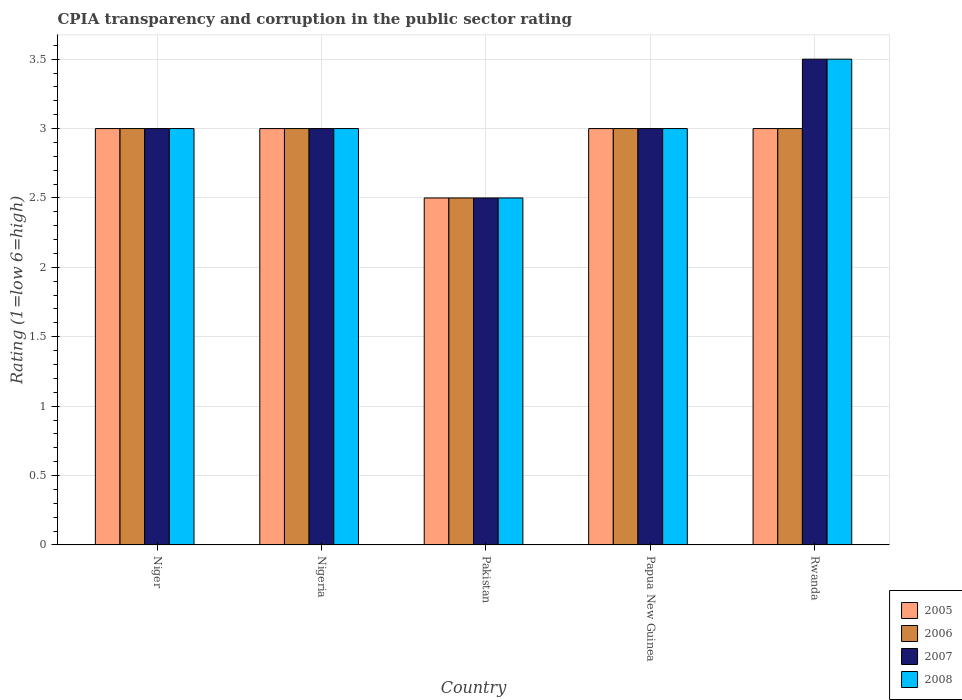Are the number of bars per tick equal to the number of legend labels?
Make the answer very short. Yes. How many bars are there on the 5th tick from the right?
Your answer should be compact. 4. What is the label of the 5th group of bars from the left?
Offer a terse response. Rwanda. In how many cases, is the number of bars for a given country not equal to the number of legend labels?
Your response must be concise. 0. What is the CPIA rating in 2007 in Niger?
Ensure brevity in your answer.  3. Across all countries, what is the maximum CPIA rating in 2008?
Give a very brief answer. 3.5. Across all countries, what is the minimum CPIA rating in 2008?
Provide a succinct answer. 2.5. In which country was the CPIA rating in 2005 maximum?
Provide a short and direct response. Niger. In which country was the CPIA rating in 2008 minimum?
Your response must be concise. Pakistan. What is the difference between the CPIA rating in 2008 in Nigeria and that in Rwanda?
Give a very brief answer. -0.5. What is the average CPIA rating in 2006 per country?
Your answer should be very brief. 2.9. What is the difference between the CPIA rating of/in 2007 and CPIA rating of/in 2006 in Rwanda?
Offer a terse response. 0.5. In how many countries, is the CPIA rating in 2008 greater than 0.30000000000000004?
Give a very brief answer. 5. What is the ratio of the CPIA rating in 2005 in Papua New Guinea to that in Rwanda?
Your response must be concise. 1. Is the CPIA rating in 2008 in Pakistan less than that in Papua New Guinea?
Offer a very short reply. Yes. Is the sum of the CPIA rating in 2006 in Pakistan and Papua New Guinea greater than the maximum CPIA rating in 2007 across all countries?
Keep it short and to the point. Yes. What does the 3rd bar from the left in Niger represents?
Provide a succinct answer. 2007. How many bars are there?
Your response must be concise. 20. Are all the bars in the graph horizontal?
Provide a succinct answer. No. How many countries are there in the graph?
Give a very brief answer. 5. Does the graph contain any zero values?
Give a very brief answer. No. Does the graph contain grids?
Make the answer very short. Yes. Where does the legend appear in the graph?
Offer a terse response. Bottom right. What is the title of the graph?
Your response must be concise. CPIA transparency and corruption in the public sector rating. What is the Rating (1=low 6=high) of 2005 in Niger?
Your answer should be very brief. 3. What is the Rating (1=low 6=high) in 2005 in Nigeria?
Offer a terse response. 3. What is the Rating (1=low 6=high) in 2008 in Pakistan?
Your answer should be very brief. 2.5. What is the Rating (1=low 6=high) of 2005 in Papua New Guinea?
Offer a very short reply. 3. What is the Rating (1=low 6=high) of 2007 in Papua New Guinea?
Provide a succinct answer. 3. What is the Rating (1=low 6=high) of 2008 in Papua New Guinea?
Your answer should be compact. 3. What is the Rating (1=low 6=high) in 2006 in Rwanda?
Offer a terse response. 3. What is the Rating (1=low 6=high) of 2007 in Rwanda?
Your answer should be compact. 3.5. Across all countries, what is the maximum Rating (1=low 6=high) in 2006?
Your response must be concise. 3. Across all countries, what is the maximum Rating (1=low 6=high) of 2008?
Keep it short and to the point. 3.5. Across all countries, what is the minimum Rating (1=low 6=high) in 2005?
Ensure brevity in your answer.  2.5. Across all countries, what is the minimum Rating (1=low 6=high) in 2006?
Make the answer very short. 2.5. Across all countries, what is the minimum Rating (1=low 6=high) of 2007?
Offer a terse response. 2.5. What is the total Rating (1=low 6=high) in 2005 in the graph?
Your response must be concise. 14.5. What is the total Rating (1=low 6=high) of 2006 in the graph?
Keep it short and to the point. 14.5. What is the total Rating (1=low 6=high) in 2008 in the graph?
Provide a succinct answer. 15. What is the difference between the Rating (1=low 6=high) of 2006 in Niger and that in Nigeria?
Provide a succinct answer. 0. What is the difference between the Rating (1=low 6=high) of 2005 in Niger and that in Pakistan?
Keep it short and to the point. 0.5. What is the difference between the Rating (1=low 6=high) of 2007 in Niger and that in Pakistan?
Your answer should be compact. 0.5. What is the difference between the Rating (1=low 6=high) of 2008 in Niger and that in Pakistan?
Your answer should be very brief. 0.5. What is the difference between the Rating (1=low 6=high) of 2005 in Niger and that in Rwanda?
Ensure brevity in your answer.  0. What is the difference between the Rating (1=low 6=high) of 2006 in Nigeria and that in Pakistan?
Offer a terse response. 0.5. What is the difference between the Rating (1=low 6=high) of 2007 in Nigeria and that in Pakistan?
Ensure brevity in your answer.  0.5. What is the difference between the Rating (1=low 6=high) of 2008 in Nigeria and that in Pakistan?
Give a very brief answer. 0.5. What is the difference between the Rating (1=low 6=high) in 2007 in Nigeria and that in Papua New Guinea?
Ensure brevity in your answer.  0. What is the difference between the Rating (1=low 6=high) of 2008 in Nigeria and that in Papua New Guinea?
Provide a short and direct response. 0. What is the difference between the Rating (1=low 6=high) of 2005 in Nigeria and that in Rwanda?
Your response must be concise. 0. What is the difference between the Rating (1=low 6=high) in 2008 in Pakistan and that in Papua New Guinea?
Your answer should be compact. -0.5. What is the difference between the Rating (1=low 6=high) in 2006 in Pakistan and that in Rwanda?
Ensure brevity in your answer.  -0.5. What is the difference between the Rating (1=low 6=high) of 2007 in Papua New Guinea and that in Rwanda?
Give a very brief answer. -0.5. What is the difference between the Rating (1=low 6=high) in 2005 in Niger and the Rating (1=low 6=high) in 2007 in Nigeria?
Ensure brevity in your answer.  0. What is the difference between the Rating (1=low 6=high) of 2006 in Niger and the Rating (1=low 6=high) of 2008 in Nigeria?
Offer a terse response. 0. What is the difference between the Rating (1=low 6=high) in 2005 in Niger and the Rating (1=low 6=high) in 2006 in Pakistan?
Offer a very short reply. 0.5. What is the difference between the Rating (1=low 6=high) of 2005 in Niger and the Rating (1=low 6=high) of 2007 in Pakistan?
Provide a short and direct response. 0.5. What is the difference between the Rating (1=low 6=high) of 2005 in Niger and the Rating (1=low 6=high) of 2008 in Pakistan?
Your answer should be compact. 0.5. What is the difference between the Rating (1=low 6=high) in 2005 in Niger and the Rating (1=low 6=high) in 2006 in Papua New Guinea?
Provide a short and direct response. 0. What is the difference between the Rating (1=low 6=high) in 2006 in Niger and the Rating (1=low 6=high) in 2008 in Papua New Guinea?
Provide a short and direct response. 0. What is the difference between the Rating (1=low 6=high) in 2007 in Niger and the Rating (1=low 6=high) in 2008 in Papua New Guinea?
Your answer should be very brief. 0. What is the difference between the Rating (1=low 6=high) of 2005 in Niger and the Rating (1=low 6=high) of 2006 in Rwanda?
Offer a very short reply. 0. What is the difference between the Rating (1=low 6=high) of 2005 in Niger and the Rating (1=low 6=high) of 2008 in Rwanda?
Offer a very short reply. -0.5. What is the difference between the Rating (1=low 6=high) in 2005 in Nigeria and the Rating (1=low 6=high) in 2008 in Pakistan?
Provide a short and direct response. 0.5. What is the difference between the Rating (1=low 6=high) of 2006 in Nigeria and the Rating (1=low 6=high) of 2008 in Pakistan?
Make the answer very short. 0.5. What is the difference between the Rating (1=low 6=high) of 2005 in Nigeria and the Rating (1=low 6=high) of 2007 in Papua New Guinea?
Keep it short and to the point. 0. What is the difference between the Rating (1=low 6=high) in 2006 in Nigeria and the Rating (1=low 6=high) in 2007 in Papua New Guinea?
Your answer should be very brief. 0. What is the difference between the Rating (1=low 6=high) in 2006 in Nigeria and the Rating (1=low 6=high) in 2008 in Papua New Guinea?
Your response must be concise. 0. What is the difference between the Rating (1=low 6=high) in 2007 in Nigeria and the Rating (1=low 6=high) in 2008 in Papua New Guinea?
Offer a very short reply. 0. What is the difference between the Rating (1=low 6=high) of 2007 in Nigeria and the Rating (1=low 6=high) of 2008 in Rwanda?
Offer a very short reply. -0.5. What is the difference between the Rating (1=low 6=high) of 2005 in Pakistan and the Rating (1=low 6=high) of 2006 in Papua New Guinea?
Ensure brevity in your answer.  -0.5. What is the difference between the Rating (1=low 6=high) of 2005 in Pakistan and the Rating (1=low 6=high) of 2008 in Papua New Guinea?
Give a very brief answer. -0.5. What is the difference between the Rating (1=low 6=high) in 2005 in Pakistan and the Rating (1=low 6=high) in 2006 in Rwanda?
Your answer should be compact. -0.5. What is the difference between the Rating (1=low 6=high) in 2005 in Pakistan and the Rating (1=low 6=high) in 2007 in Rwanda?
Offer a very short reply. -1. What is the difference between the Rating (1=low 6=high) in 2006 in Pakistan and the Rating (1=low 6=high) in 2007 in Rwanda?
Your answer should be very brief. -1. What is the difference between the Rating (1=low 6=high) of 2007 in Pakistan and the Rating (1=low 6=high) of 2008 in Rwanda?
Offer a terse response. -1. What is the difference between the Rating (1=low 6=high) in 2005 in Papua New Guinea and the Rating (1=low 6=high) in 2006 in Rwanda?
Make the answer very short. 0. What is the difference between the Rating (1=low 6=high) in 2005 in Papua New Guinea and the Rating (1=low 6=high) in 2007 in Rwanda?
Offer a very short reply. -0.5. What is the difference between the Rating (1=low 6=high) in 2005 in Papua New Guinea and the Rating (1=low 6=high) in 2008 in Rwanda?
Your answer should be very brief. -0.5. What is the average Rating (1=low 6=high) in 2006 per country?
Ensure brevity in your answer.  2.9. What is the average Rating (1=low 6=high) in 2007 per country?
Ensure brevity in your answer.  3. What is the difference between the Rating (1=low 6=high) in 2005 and Rating (1=low 6=high) in 2007 in Niger?
Offer a very short reply. 0. What is the difference between the Rating (1=low 6=high) of 2006 and Rating (1=low 6=high) of 2007 in Niger?
Ensure brevity in your answer.  0. What is the difference between the Rating (1=low 6=high) of 2006 and Rating (1=low 6=high) of 2008 in Niger?
Your answer should be very brief. 0. What is the difference between the Rating (1=low 6=high) in 2005 and Rating (1=low 6=high) in 2008 in Nigeria?
Give a very brief answer. 0. What is the difference between the Rating (1=low 6=high) in 2006 and Rating (1=low 6=high) in 2007 in Nigeria?
Your answer should be very brief. 0. What is the difference between the Rating (1=low 6=high) of 2006 and Rating (1=low 6=high) of 2008 in Nigeria?
Ensure brevity in your answer.  0. What is the difference between the Rating (1=low 6=high) of 2007 and Rating (1=low 6=high) of 2008 in Nigeria?
Offer a terse response. 0. What is the difference between the Rating (1=low 6=high) in 2005 and Rating (1=low 6=high) in 2007 in Pakistan?
Your answer should be compact. 0. What is the difference between the Rating (1=low 6=high) of 2005 and Rating (1=low 6=high) of 2008 in Pakistan?
Make the answer very short. 0. What is the difference between the Rating (1=low 6=high) of 2006 and Rating (1=low 6=high) of 2007 in Pakistan?
Your response must be concise. 0. What is the difference between the Rating (1=low 6=high) in 2005 and Rating (1=low 6=high) in 2006 in Papua New Guinea?
Your answer should be compact. 0. What is the difference between the Rating (1=low 6=high) of 2005 and Rating (1=low 6=high) of 2007 in Papua New Guinea?
Ensure brevity in your answer.  0. What is the difference between the Rating (1=low 6=high) in 2005 and Rating (1=low 6=high) in 2008 in Papua New Guinea?
Your answer should be compact. 0. What is the difference between the Rating (1=low 6=high) of 2006 and Rating (1=low 6=high) of 2008 in Papua New Guinea?
Provide a short and direct response. 0. What is the difference between the Rating (1=low 6=high) in 2005 and Rating (1=low 6=high) in 2007 in Rwanda?
Offer a very short reply. -0.5. What is the difference between the Rating (1=low 6=high) in 2006 and Rating (1=low 6=high) in 2007 in Rwanda?
Provide a succinct answer. -0.5. What is the ratio of the Rating (1=low 6=high) in 2006 in Niger to that in Nigeria?
Offer a very short reply. 1. What is the ratio of the Rating (1=low 6=high) of 2007 in Niger to that in Nigeria?
Provide a succinct answer. 1. What is the ratio of the Rating (1=low 6=high) in 2005 in Niger to that in Pakistan?
Your answer should be compact. 1.2. What is the ratio of the Rating (1=low 6=high) in 2008 in Niger to that in Pakistan?
Your answer should be compact. 1.2. What is the ratio of the Rating (1=low 6=high) in 2006 in Niger to that in Papua New Guinea?
Give a very brief answer. 1. What is the ratio of the Rating (1=low 6=high) in 2007 in Niger to that in Papua New Guinea?
Your answer should be very brief. 1. What is the ratio of the Rating (1=low 6=high) of 2006 in Niger to that in Rwanda?
Your response must be concise. 1. What is the ratio of the Rating (1=low 6=high) of 2007 in Niger to that in Rwanda?
Ensure brevity in your answer.  0.86. What is the ratio of the Rating (1=low 6=high) of 2008 in Niger to that in Rwanda?
Your answer should be very brief. 0.86. What is the ratio of the Rating (1=low 6=high) of 2008 in Nigeria to that in Pakistan?
Offer a terse response. 1.2. What is the ratio of the Rating (1=low 6=high) of 2005 in Nigeria to that in Papua New Guinea?
Make the answer very short. 1. What is the ratio of the Rating (1=low 6=high) of 2008 in Nigeria to that in Papua New Guinea?
Your answer should be very brief. 1. What is the ratio of the Rating (1=low 6=high) in 2005 in Nigeria to that in Rwanda?
Your response must be concise. 1. What is the ratio of the Rating (1=low 6=high) of 2006 in Nigeria to that in Rwanda?
Your answer should be very brief. 1. What is the ratio of the Rating (1=low 6=high) of 2008 in Nigeria to that in Rwanda?
Make the answer very short. 0.86. What is the ratio of the Rating (1=low 6=high) of 2005 in Pakistan to that in Papua New Guinea?
Keep it short and to the point. 0.83. What is the ratio of the Rating (1=low 6=high) of 2006 in Pakistan to that in Papua New Guinea?
Give a very brief answer. 0.83. What is the ratio of the Rating (1=low 6=high) in 2007 in Pakistan to that in Papua New Guinea?
Make the answer very short. 0.83. What is the ratio of the Rating (1=low 6=high) of 2008 in Pakistan to that in Papua New Guinea?
Your answer should be very brief. 0.83. What is the ratio of the Rating (1=low 6=high) of 2005 in Pakistan to that in Rwanda?
Ensure brevity in your answer.  0.83. What is the ratio of the Rating (1=low 6=high) in 2008 in Pakistan to that in Rwanda?
Offer a very short reply. 0.71. What is the ratio of the Rating (1=low 6=high) in 2005 in Papua New Guinea to that in Rwanda?
Your response must be concise. 1. What is the ratio of the Rating (1=low 6=high) in 2007 in Papua New Guinea to that in Rwanda?
Your answer should be very brief. 0.86. What is the ratio of the Rating (1=low 6=high) of 2008 in Papua New Guinea to that in Rwanda?
Give a very brief answer. 0.86. What is the difference between the highest and the second highest Rating (1=low 6=high) of 2005?
Make the answer very short. 0. What is the difference between the highest and the second highest Rating (1=low 6=high) of 2007?
Offer a terse response. 0.5. What is the difference between the highest and the lowest Rating (1=low 6=high) of 2005?
Offer a terse response. 0.5. What is the difference between the highest and the lowest Rating (1=low 6=high) of 2006?
Give a very brief answer. 0.5. What is the difference between the highest and the lowest Rating (1=low 6=high) in 2008?
Give a very brief answer. 1. 